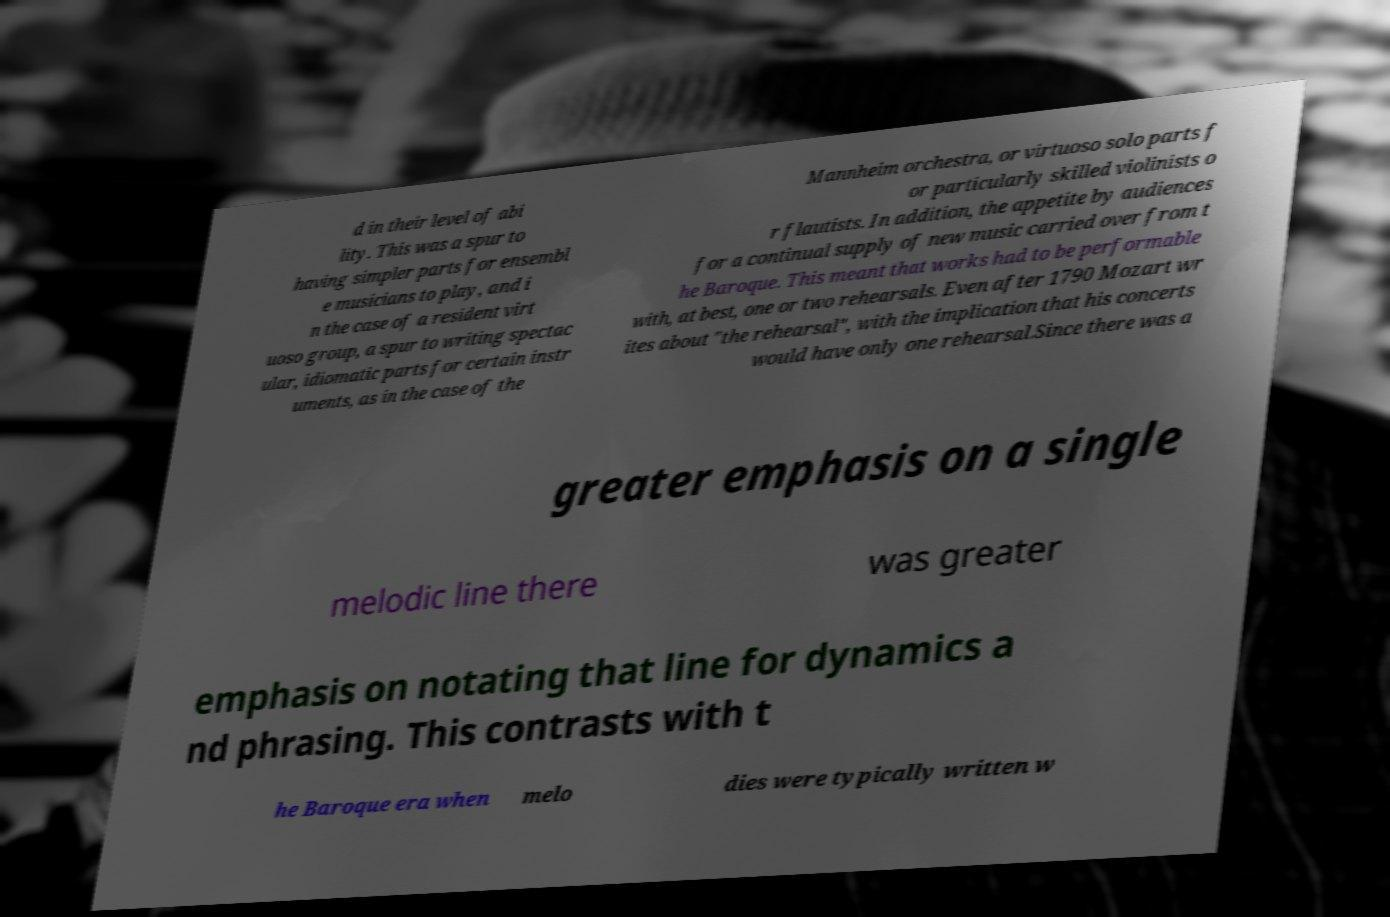For documentation purposes, I need the text within this image transcribed. Could you provide that? d in their level of abi lity. This was a spur to having simpler parts for ensembl e musicians to play, and i n the case of a resident virt uoso group, a spur to writing spectac ular, idiomatic parts for certain instr uments, as in the case of the Mannheim orchestra, or virtuoso solo parts f or particularly skilled violinists o r flautists. In addition, the appetite by audiences for a continual supply of new music carried over from t he Baroque. This meant that works had to be performable with, at best, one or two rehearsals. Even after 1790 Mozart wr ites about "the rehearsal", with the implication that his concerts would have only one rehearsal.Since there was a greater emphasis on a single melodic line there was greater emphasis on notating that line for dynamics a nd phrasing. This contrasts with t he Baroque era when melo dies were typically written w 